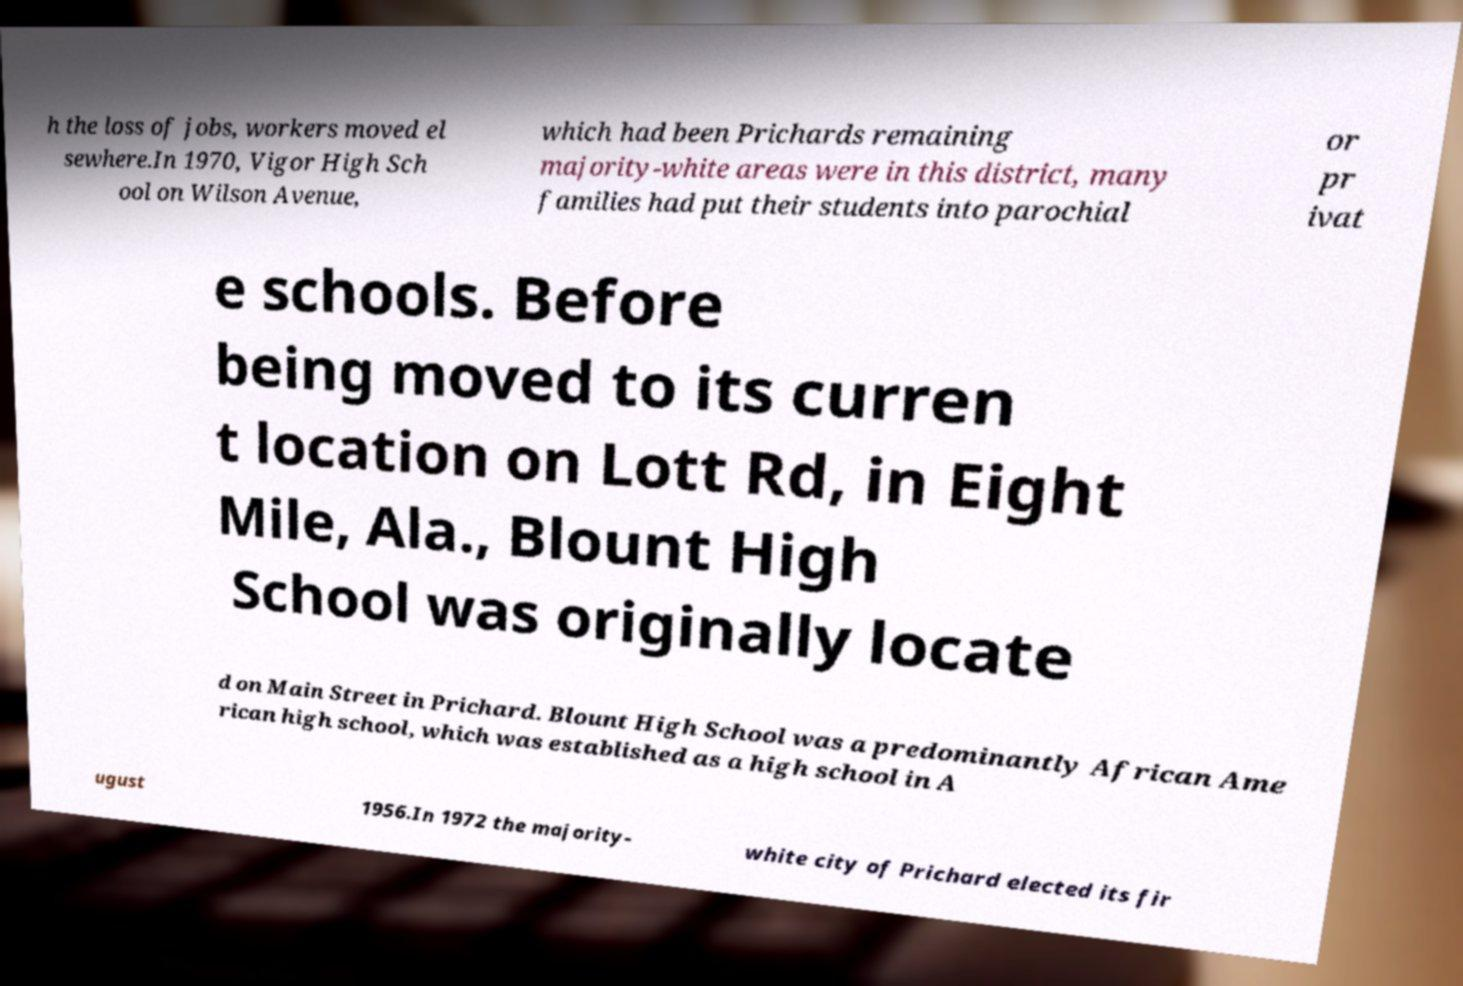There's text embedded in this image that I need extracted. Can you transcribe it verbatim? h the loss of jobs, workers moved el sewhere.In 1970, Vigor High Sch ool on Wilson Avenue, which had been Prichards remaining majority-white areas were in this district, many families had put their students into parochial or pr ivat e schools. Before being moved to its curren t location on Lott Rd, in Eight Mile, Ala., Blount High School was originally locate d on Main Street in Prichard. Blount High School was a predominantly African Ame rican high school, which was established as a high school in A ugust 1956.In 1972 the majority- white city of Prichard elected its fir 